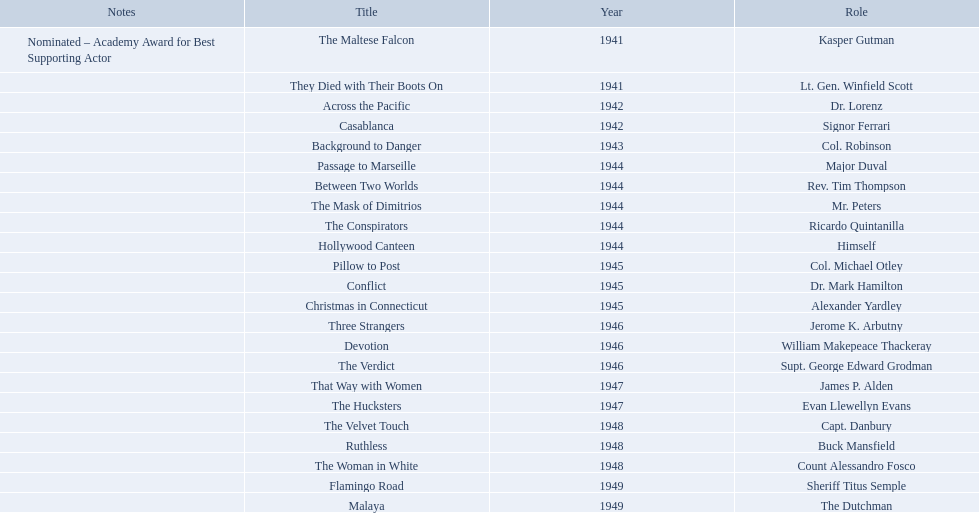What year was the movie that was nominated ? 1941. What was the title of the movie? The Maltese Falcon. 